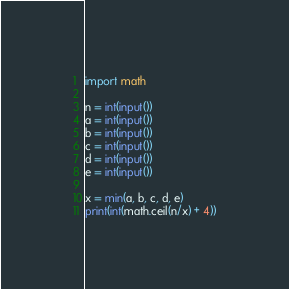Convert code to text. <code><loc_0><loc_0><loc_500><loc_500><_Python_>import math

n = int(input())
a = int(input())
b = int(input())
c = int(input())
d = int(input())
e = int(input())

x = min(a, b, c, d, e)
print(int(math.ceil(n/x) + 4))
</code> 